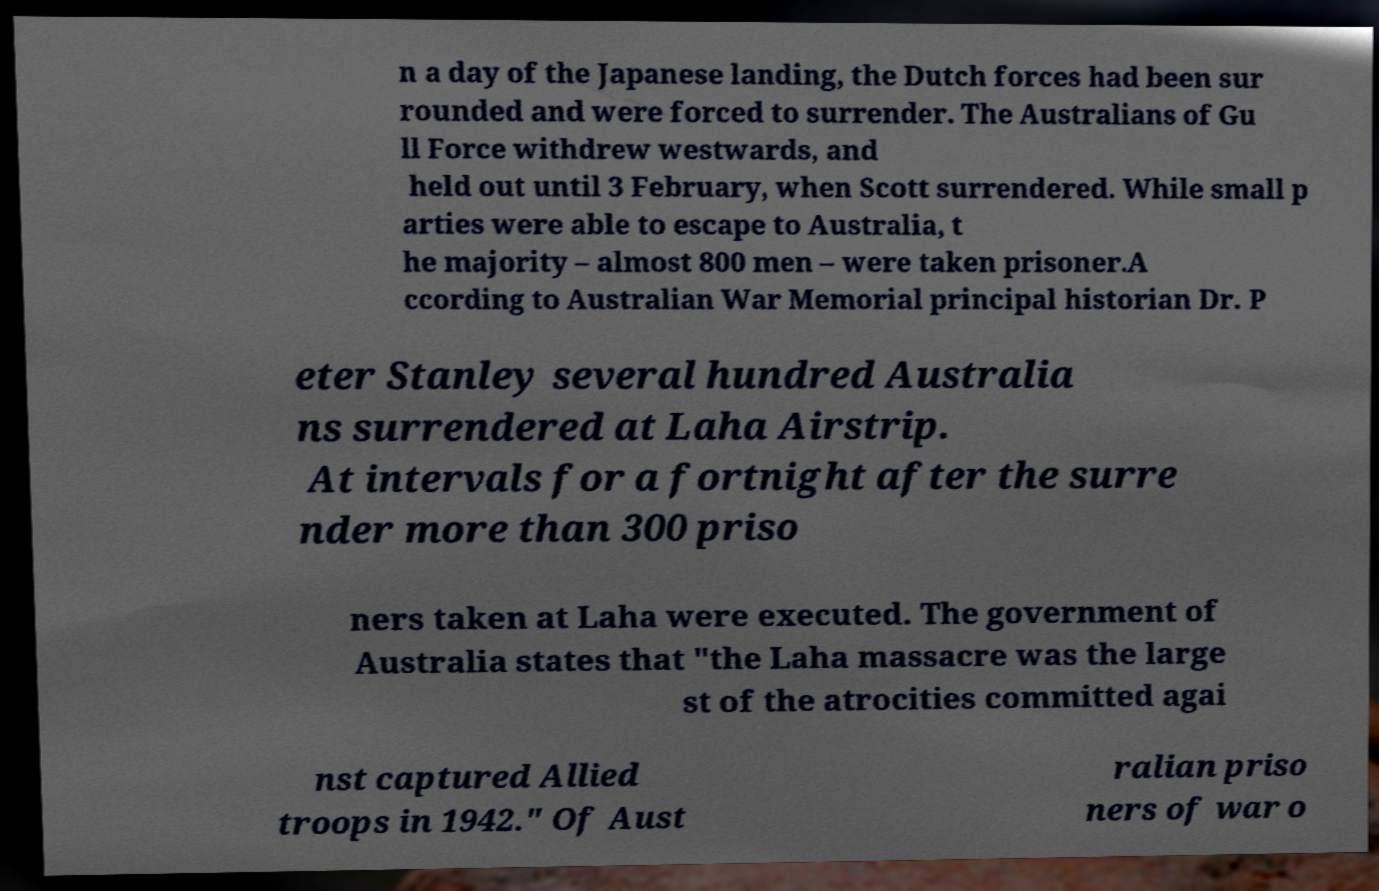There's text embedded in this image that I need extracted. Can you transcribe it verbatim? n a day of the Japanese landing, the Dutch forces had been sur rounded and were forced to surrender. The Australians of Gu ll Force withdrew westwards, and held out until 3 February, when Scott surrendered. While small p arties were able to escape to Australia, t he majority – almost 800 men – were taken prisoner.A ccording to Australian War Memorial principal historian Dr. P eter Stanley several hundred Australia ns surrendered at Laha Airstrip. At intervals for a fortnight after the surre nder more than 300 priso ners taken at Laha were executed. The government of Australia states that "the Laha massacre was the large st of the atrocities committed agai nst captured Allied troops in 1942." Of Aust ralian priso ners of war o 